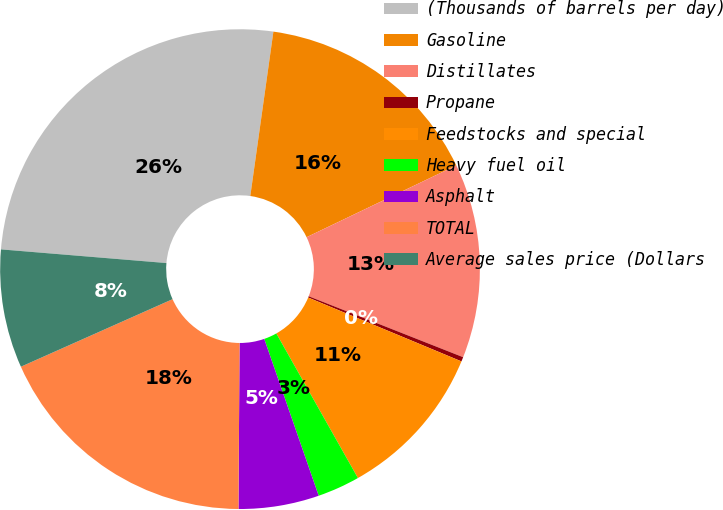<chart> <loc_0><loc_0><loc_500><loc_500><pie_chart><fcel>(Thousands of barrels per day)<fcel>Gasoline<fcel>Distillates<fcel>Propane<fcel>Feedstocks and special<fcel>Heavy fuel oil<fcel>Asphalt<fcel>TOTAL<fcel>Average sales price (Dollars<nl><fcel>25.91%<fcel>15.66%<fcel>13.1%<fcel>0.3%<fcel>10.54%<fcel>2.86%<fcel>5.42%<fcel>18.23%<fcel>7.98%<nl></chart> 